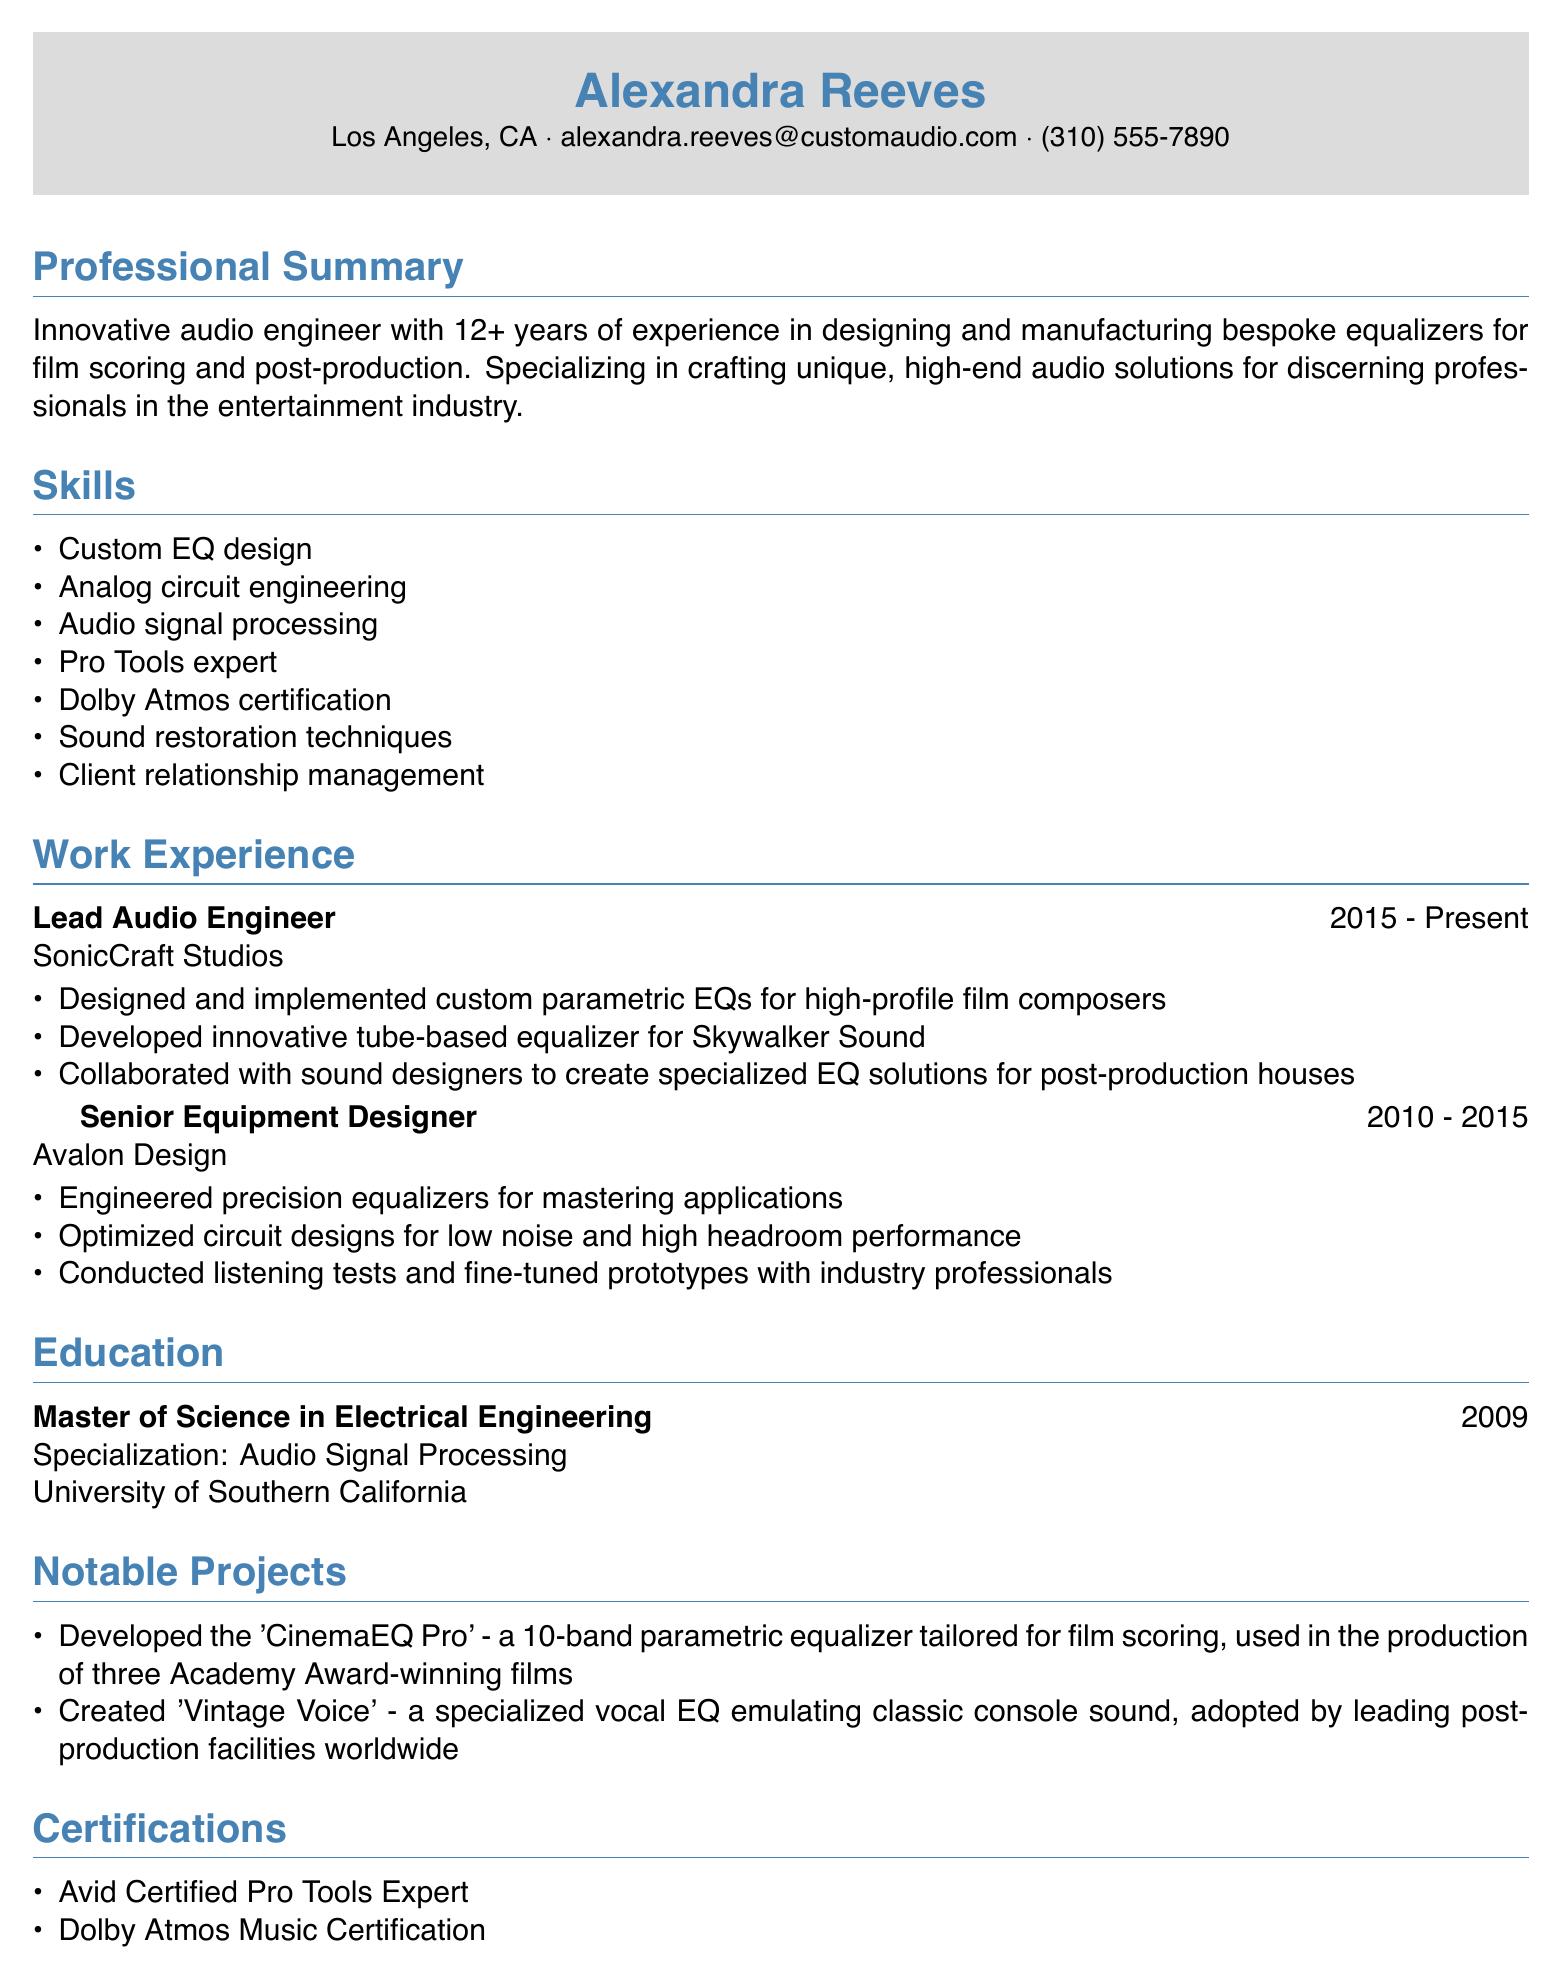What is the name of the candidate? The name of the candidate is clearly stated in the personal information section.
Answer: Alexandra Reeves What is the location of the candidate? The location is found in the personal information section of the CV.
Answer: Los Angeles, CA How many years of experience does the candidate have? The professional summary mentions the total years of experience directly.
Answer: 12+ What is the position held at SonicCraft Studios? The work experience section specifies the role at SonicCraft Studios.
Answer: Lead Audio Engineer What notable project was developed by Alexandra Reeves? The notable projects section includes specific projects attributed to the candidate.
Answer: CinemaEQ Pro What degree did the candidate earn? The education section lists the degree obtained by the candidate.
Answer: Master of Science in Electrical Engineering What certification does the candidate have related to Pro Tools? The certifications section outlines specific certifications obtained by the candidate.
Answer: Avid Certified Pro Tools Expert What is the focus of expertise for the candidate? The professional summary gives insight into the candidate's area of specialization.
Answer: Bespoke equalizers for film scoring and post-production How long did the candidate work at Avalon Design? The work experience section indicates the duration of employment at Avalon Design.
Answer: 2010 - 2015 